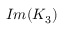Convert formula to latex. <formula><loc_0><loc_0><loc_500><loc_500>I m ( K _ { 3 } )</formula> 